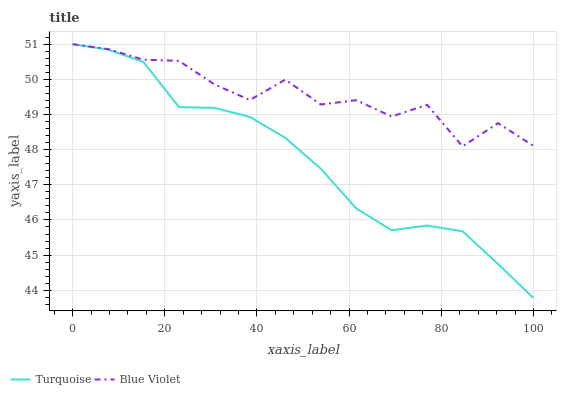Does Turquoise have the minimum area under the curve?
Answer yes or no. Yes. Does Blue Violet have the maximum area under the curve?
Answer yes or no. Yes. Does Blue Violet have the minimum area under the curve?
Answer yes or no. No. Is Turquoise the smoothest?
Answer yes or no. Yes. Is Blue Violet the roughest?
Answer yes or no. Yes. Is Blue Violet the smoothest?
Answer yes or no. No. Does Turquoise have the lowest value?
Answer yes or no. Yes. Does Blue Violet have the lowest value?
Answer yes or no. No. Does Blue Violet have the highest value?
Answer yes or no. Yes. Does Blue Violet intersect Turquoise?
Answer yes or no. Yes. Is Blue Violet less than Turquoise?
Answer yes or no. No. Is Blue Violet greater than Turquoise?
Answer yes or no. No. 